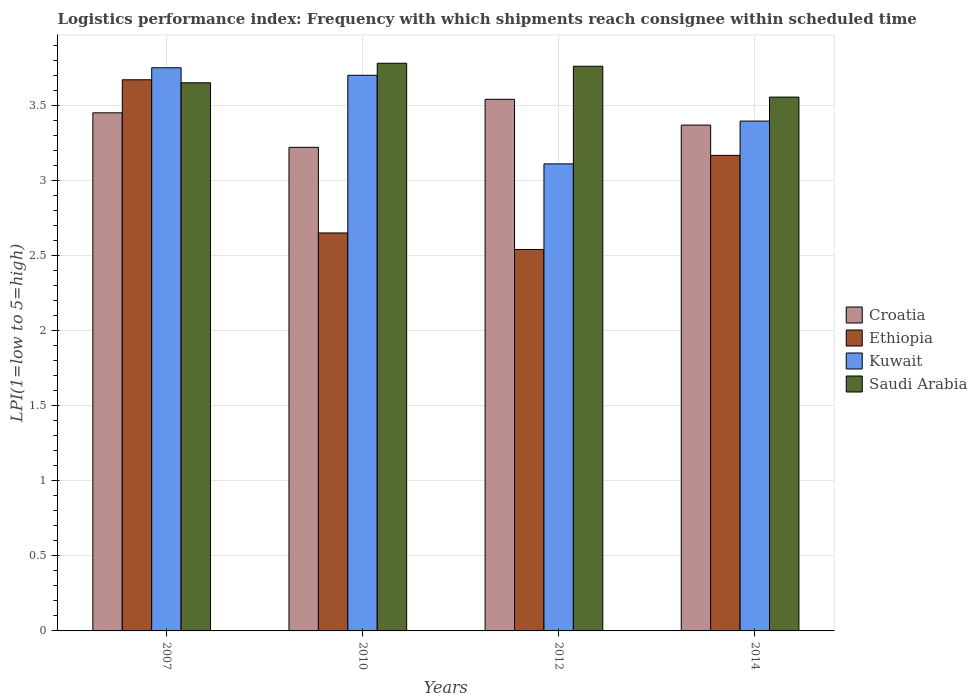How many different coloured bars are there?
Your response must be concise. 4. How many bars are there on the 2nd tick from the right?
Make the answer very short. 4. In how many cases, is the number of bars for a given year not equal to the number of legend labels?
Offer a terse response. 0. What is the logistics performance index in Croatia in 2014?
Give a very brief answer. 3.37. Across all years, what is the maximum logistics performance index in Ethiopia?
Give a very brief answer. 3.67. Across all years, what is the minimum logistics performance index in Kuwait?
Your answer should be compact. 3.11. In which year was the logistics performance index in Ethiopia maximum?
Provide a short and direct response. 2007. What is the total logistics performance index in Saudi Arabia in the graph?
Give a very brief answer. 14.74. What is the difference between the logistics performance index in Kuwait in 2010 and that in 2012?
Make the answer very short. 0.59. What is the difference between the logistics performance index in Kuwait in 2010 and the logistics performance index in Ethiopia in 2012?
Give a very brief answer. 1.16. What is the average logistics performance index in Kuwait per year?
Give a very brief answer. 3.49. In the year 2014, what is the difference between the logistics performance index in Ethiopia and logistics performance index in Croatia?
Your answer should be compact. -0.2. In how many years, is the logistics performance index in Kuwait greater than 2.3?
Your answer should be compact. 4. What is the ratio of the logistics performance index in Ethiopia in 2010 to that in 2012?
Your response must be concise. 1.04. Is the logistics performance index in Ethiopia in 2010 less than that in 2012?
Make the answer very short. No. Is the difference between the logistics performance index in Ethiopia in 2012 and 2014 greater than the difference between the logistics performance index in Croatia in 2012 and 2014?
Provide a succinct answer. No. What is the difference between the highest and the second highest logistics performance index in Croatia?
Keep it short and to the point. 0.09. What is the difference between the highest and the lowest logistics performance index in Ethiopia?
Your response must be concise. 1.13. In how many years, is the logistics performance index in Kuwait greater than the average logistics performance index in Kuwait taken over all years?
Make the answer very short. 2. Is the sum of the logistics performance index in Saudi Arabia in 2007 and 2014 greater than the maximum logistics performance index in Kuwait across all years?
Keep it short and to the point. Yes. Is it the case that in every year, the sum of the logistics performance index in Croatia and logistics performance index in Saudi Arabia is greater than the sum of logistics performance index in Ethiopia and logistics performance index in Kuwait?
Provide a succinct answer. Yes. What does the 3rd bar from the left in 2012 represents?
Your answer should be very brief. Kuwait. What does the 2nd bar from the right in 2007 represents?
Your answer should be very brief. Kuwait. Is it the case that in every year, the sum of the logistics performance index in Croatia and logistics performance index in Saudi Arabia is greater than the logistics performance index in Kuwait?
Give a very brief answer. Yes. Are all the bars in the graph horizontal?
Your answer should be very brief. No. How many years are there in the graph?
Offer a very short reply. 4. What is the difference between two consecutive major ticks on the Y-axis?
Your answer should be very brief. 0.5. Are the values on the major ticks of Y-axis written in scientific E-notation?
Give a very brief answer. No. Does the graph contain grids?
Keep it short and to the point. Yes. How many legend labels are there?
Provide a succinct answer. 4. What is the title of the graph?
Ensure brevity in your answer.  Logistics performance index: Frequency with which shipments reach consignee within scheduled time. What is the label or title of the Y-axis?
Provide a succinct answer. LPI(1=low to 5=high). What is the LPI(1=low to 5=high) of Croatia in 2007?
Make the answer very short. 3.45. What is the LPI(1=low to 5=high) of Ethiopia in 2007?
Keep it short and to the point. 3.67. What is the LPI(1=low to 5=high) in Kuwait in 2007?
Ensure brevity in your answer.  3.75. What is the LPI(1=low to 5=high) of Saudi Arabia in 2007?
Provide a short and direct response. 3.65. What is the LPI(1=low to 5=high) in Croatia in 2010?
Offer a terse response. 3.22. What is the LPI(1=low to 5=high) of Ethiopia in 2010?
Provide a succinct answer. 2.65. What is the LPI(1=low to 5=high) in Saudi Arabia in 2010?
Your answer should be compact. 3.78. What is the LPI(1=low to 5=high) in Croatia in 2012?
Your answer should be compact. 3.54. What is the LPI(1=low to 5=high) in Ethiopia in 2012?
Your answer should be compact. 2.54. What is the LPI(1=low to 5=high) of Kuwait in 2012?
Ensure brevity in your answer.  3.11. What is the LPI(1=low to 5=high) of Saudi Arabia in 2012?
Provide a succinct answer. 3.76. What is the LPI(1=low to 5=high) of Croatia in 2014?
Make the answer very short. 3.37. What is the LPI(1=low to 5=high) in Ethiopia in 2014?
Make the answer very short. 3.17. What is the LPI(1=low to 5=high) of Kuwait in 2014?
Your answer should be very brief. 3.39. What is the LPI(1=low to 5=high) in Saudi Arabia in 2014?
Your answer should be very brief. 3.55. Across all years, what is the maximum LPI(1=low to 5=high) in Croatia?
Offer a terse response. 3.54. Across all years, what is the maximum LPI(1=low to 5=high) in Ethiopia?
Your answer should be compact. 3.67. Across all years, what is the maximum LPI(1=low to 5=high) in Kuwait?
Give a very brief answer. 3.75. Across all years, what is the maximum LPI(1=low to 5=high) in Saudi Arabia?
Give a very brief answer. 3.78. Across all years, what is the minimum LPI(1=low to 5=high) in Croatia?
Your response must be concise. 3.22. Across all years, what is the minimum LPI(1=low to 5=high) of Ethiopia?
Your answer should be very brief. 2.54. Across all years, what is the minimum LPI(1=low to 5=high) in Kuwait?
Give a very brief answer. 3.11. Across all years, what is the minimum LPI(1=low to 5=high) of Saudi Arabia?
Your answer should be very brief. 3.55. What is the total LPI(1=low to 5=high) in Croatia in the graph?
Your answer should be very brief. 13.58. What is the total LPI(1=low to 5=high) of Ethiopia in the graph?
Offer a terse response. 12.03. What is the total LPI(1=low to 5=high) in Kuwait in the graph?
Provide a succinct answer. 13.96. What is the total LPI(1=low to 5=high) in Saudi Arabia in the graph?
Your response must be concise. 14.74. What is the difference between the LPI(1=low to 5=high) in Croatia in 2007 and that in 2010?
Your answer should be very brief. 0.23. What is the difference between the LPI(1=low to 5=high) in Ethiopia in 2007 and that in 2010?
Your response must be concise. 1.02. What is the difference between the LPI(1=low to 5=high) of Saudi Arabia in 2007 and that in 2010?
Your answer should be very brief. -0.13. What is the difference between the LPI(1=low to 5=high) of Croatia in 2007 and that in 2012?
Offer a terse response. -0.09. What is the difference between the LPI(1=low to 5=high) of Ethiopia in 2007 and that in 2012?
Offer a terse response. 1.13. What is the difference between the LPI(1=low to 5=high) of Kuwait in 2007 and that in 2012?
Make the answer very short. 0.64. What is the difference between the LPI(1=low to 5=high) in Saudi Arabia in 2007 and that in 2012?
Provide a short and direct response. -0.11. What is the difference between the LPI(1=low to 5=high) of Croatia in 2007 and that in 2014?
Keep it short and to the point. 0.08. What is the difference between the LPI(1=low to 5=high) in Ethiopia in 2007 and that in 2014?
Keep it short and to the point. 0.5. What is the difference between the LPI(1=low to 5=high) of Kuwait in 2007 and that in 2014?
Your answer should be very brief. 0.35. What is the difference between the LPI(1=low to 5=high) of Saudi Arabia in 2007 and that in 2014?
Keep it short and to the point. 0.1. What is the difference between the LPI(1=low to 5=high) in Croatia in 2010 and that in 2012?
Your answer should be very brief. -0.32. What is the difference between the LPI(1=low to 5=high) in Ethiopia in 2010 and that in 2012?
Offer a very short reply. 0.11. What is the difference between the LPI(1=low to 5=high) in Kuwait in 2010 and that in 2012?
Provide a succinct answer. 0.59. What is the difference between the LPI(1=low to 5=high) in Saudi Arabia in 2010 and that in 2012?
Make the answer very short. 0.02. What is the difference between the LPI(1=low to 5=high) in Croatia in 2010 and that in 2014?
Keep it short and to the point. -0.15. What is the difference between the LPI(1=low to 5=high) in Ethiopia in 2010 and that in 2014?
Your answer should be very brief. -0.52. What is the difference between the LPI(1=low to 5=high) in Kuwait in 2010 and that in 2014?
Provide a succinct answer. 0.3. What is the difference between the LPI(1=low to 5=high) of Saudi Arabia in 2010 and that in 2014?
Your answer should be compact. 0.23. What is the difference between the LPI(1=low to 5=high) of Croatia in 2012 and that in 2014?
Provide a short and direct response. 0.17. What is the difference between the LPI(1=low to 5=high) in Ethiopia in 2012 and that in 2014?
Make the answer very short. -0.63. What is the difference between the LPI(1=low to 5=high) in Kuwait in 2012 and that in 2014?
Offer a very short reply. -0.28. What is the difference between the LPI(1=low to 5=high) of Saudi Arabia in 2012 and that in 2014?
Ensure brevity in your answer.  0.21. What is the difference between the LPI(1=low to 5=high) of Croatia in 2007 and the LPI(1=low to 5=high) of Kuwait in 2010?
Your response must be concise. -0.25. What is the difference between the LPI(1=low to 5=high) of Croatia in 2007 and the LPI(1=low to 5=high) of Saudi Arabia in 2010?
Offer a terse response. -0.33. What is the difference between the LPI(1=low to 5=high) in Ethiopia in 2007 and the LPI(1=low to 5=high) in Kuwait in 2010?
Offer a terse response. -0.03. What is the difference between the LPI(1=low to 5=high) of Ethiopia in 2007 and the LPI(1=low to 5=high) of Saudi Arabia in 2010?
Provide a succinct answer. -0.11. What is the difference between the LPI(1=low to 5=high) of Kuwait in 2007 and the LPI(1=low to 5=high) of Saudi Arabia in 2010?
Your answer should be compact. -0.03. What is the difference between the LPI(1=low to 5=high) in Croatia in 2007 and the LPI(1=low to 5=high) in Ethiopia in 2012?
Your answer should be compact. 0.91. What is the difference between the LPI(1=low to 5=high) in Croatia in 2007 and the LPI(1=low to 5=high) in Kuwait in 2012?
Offer a terse response. 0.34. What is the difference between the LPI(1=low to 5=high) in Croatia in 2007 and the LPI(1=low to 5=high) in Saudi Arabia in 2012?
Offer a terse response. -0.31. What is the difference between the LPI(1=low to 5=high) in Ethiopia in 2007 and the LPI(1=low to 5=high) in Kuwait in 2012?
Provide a succinct answer. 0.56. What is the difference between the LPI(1=low to 5=high) of Ethiopia in 2007 and the LPI(1=low to 5=high) of Saudi Arabia in 2012?
Your answer should be compact. -0.09. What is the difference between the LPI(1=low to 5=high) in Kuwait in 2007 and the LPI(1=low to 5=high) in Saudi Arabia in 2012?
Make the answer very short. -0.01. What is the difference between the LPI(1=low to 5=high) of Croatia in 2007 and the LPI(1=low to 5=high) of Ethiopia in 2014?
Keep it short and to the point. 0.28. What is the difference between the LPI(1=low to 5=high) of Croatia in 2007 and the LPI(1=low to 5=high) of Kuwait in 2014?
Make the answer very short. 0.06. What is the difference between the LPI(1=low to 5=high) in Croatia in 2007 and the LPI(1=low to 5=high) in Saudi Arabia in 2014?
Your answer should be compact. -0.1. What is the difference between the LPI(1=low to 5=high) in Ethiopia in 2007 and the LPI(1=low to 5=high) in Kuwait in 2014?
Keep it short and to the point. 0.28. What is the difference between the LPI(1=low to 5=high) of Ethiopia in 2007 and the LPI(1=low to 5=high) of Saudi Arabia in 2014?
Keep it short and to the point. 0.12. What is the difference between the LPI(1=low to 5=high) in Kuwait in 2007 and the LPI(1=low to 5=high) in Saudi Arabia in 2014?
Your answer should be compact. 0.2. What is the difference between the LPI(1=low to 5=high) of Croatia in 2010 and the LPI(1=low to 5=high) of Ethiopia in 2012?
Offer a terse response. 0.68. What is the difference between the LPI(1=low to 5=high) of Croatia in 2010 and the LPI(1=low to 5=high) of Kuwait in 2012?
Offer a terse response. 0.11. What is the difference between the LPI(1=low to 5=high) in Croatia in 2010 and the LPI(1=low to 5=high) in Saudi Arabia in 2012?
Offer a very short reply. -0.54. What is the difference between the LPI(1=low to 5=high) in Ethiopia in 2010 and the LPI(1=low to 5=high) in Kuwait in 2012?
Provide a succinct answer. -0.46. What is the difference between the LPI(1=low to 5=high) of Ethiopia in 2010 and the LPI(1=low to 5=high) of Saudi Arabia in 2012?
Provide a succinct answer. -1.11. What is the difference between the LPI(1=low to 5=high) of Kuwait in 2010 and the LPI(1=low to 5=high) of Saudi Arabia in 2012?
Your response must be concise. -0.06. What is the difference between the LPI(1=low to 5=high) in Croatia in 2010 and the LPI(1=low to 5=high) in Ethiopia in 2014?
Provide a succinct answer. 0.05. What is the difference between the LPI(1=low to 5=high) of Croatia in 2010 and the LPI(1=low to 5=high) of Kuwait in 2014?
Make the answer very short. -0.17. What is the difference between the LPI(1=low to 5=high) of Croatia in 2010 and the LPI(1=low to 5=high) of Saudi Arabia in 2014?
Your response must be concise. -0.33. What is the difference between the LPI(1=low to 5=high) of Ethiopia in 2010 and the LPI(1=low to 5=high) of Kuwait in 2014?
Provide a succinct answer. -0.74. What is the difference between the LPI(1=low to 5=high) in Ethiopia in 2010 and the LPI(1=low to 5=high) in Saudi Arabia in 2014?
Offer a very short reply. -0.9. What is the difference between the LPI(1=low to 5=high) of Kuwait in 2010 and the LPI(1=low to 5=high) of Saudi Arabia in 2014?
Your answer should be very brief. 0.15. What is the difference between the LPI(1=low to 5=high) of Croatia in 2012 and the LPI(1=low to 5=high) of Ethiopia in 2014?
Your response must be concise. 0.37. What is the difference between the LPI(1=low to 5=high) in Croatia in 2012 and the LPI(1=low to 5=high) in Kuwait in 2014?
Offer a terse response. 0.14. What is the difference between the LPI(1=low to 5=high) of Croatia in 2012 and the LPI(1=low to 5=high) of Saudi Arabia in 2014?
Provide a short and direct response. -0.01. What is the difference between the LPI(1=low to 5=high) in Ethiopia in 2012 and the LPI(1=low to 5=high) in Kuwait in 2014?
Offer a terse response. -0.85. What is the difference between the LPI(1=low to 5=high) of Ethiopia in 2012 and the LPI(1=low to 5=high) of Saudi Arabia in 2014?
Provide a short and direct response. -1.01. What is the difference between the LPI(1=low to 5=high) of Kuwait in 2012 and the LPI(1=low to 5=high) of Saudi Arabia in 2014?
Make the answer very short. -0.44. What is the average LPI(1=low to 5=high) of Croatia per year?
Give a very brief answer. 3.39. What is the average LPI(1=low to 5=high) in Ethiopia per year?
Give a very brief answer. 3.01. What is the average LPI(1=low to 5=high) of Kuwait per year?
Your answer should be very brief. 3.49. What is the average LPI(1=low to 5=high) in Saudi Arabia per year?
Give a very brief answer. 3.69. In the year 2007, what is the difference between the LPI(1=low to 5=high) in Croatia and LPI(1=low to 5=high) in Ethiopia?
Offer a terse response. -0.22. In the year 2007, what is the difference between the LPI(1=low to 5=high) of Croatia and LPI(1=low to 5=high) of Kuwait?
Your answer should be compact. -0.3. In the year 2007, what is the difference between the LPI(1=low to 5=high) of Ethiopia and LPI(1=low to 5=high) of Kuwait?
Provide a succinct answer. -0.08. In the year 2007, what is the difference between the LPI(1=low to 5=high) of Kuwait and LPI(1=low to 5=high) of Saudi Arabia?
Offer a terse response. 0.1. In the year 2010, what is the difference between the LPI(1=low to 5=high) of Croatia and LPI(1=low to 5=high) of Ethiopia?
Keep it short and to the point. 0.57. In the year 2010, what is the difference between the LPI(1=low to 5=high) of Croatia and LPI(1=low to 5=high) of Kuwait?
Give a very brief answer. -0.48. In the year 2010, what is the difference between the LPI(1=low to 5=high) of Croatia and LPI(1=low to 5=high) of Saudi Arabia?
Offer a very short reply. -0.56. In the year 2010, what is the difference between the LPI(1=low to 5=high) of Ethiopia and LPI(1=low to 5=high) of Kuwait?
Make the answer very short. -1.05. In the year 2010, what is the difference between the LPI(1=low to 5=high) of Ethiopia and LPI(1=low to 5=high) of Saudi Arabia?
Offer a terse response. -1.13. In the year 2010, what is the difference between the LPI(1=low to 5=high) of Kuwait and LPI(1=low to 5=high) of Saudi Arabia?
Offer a terse response. -0.08. In the year 2012, what is the difference between the LPI(1=low to 5=high) in Croatia and LPI(1=low to 5=high) in Ethiopia?
Give a very brief answer. 1. In the year 2012, what is the difference between the LPI(1=low to 5=high) of Croatia and LPI(1=low to 5=high) of Kuwait?
Your answer should be compact. 0.43. In the year 2012, what is the difference between the LPI(1=low to 5=high) of Croatia and LPI(1=low to 5=high) of Saudi Arabia?
Keep it short and to the point. -0.22. In the year 2012, what is the difference between the LPI(1=low to 5=high) in Ethiopia and LPI(1=low to 5=high) in Kuwait?
Your answer should be very brief. -0.57. In the year 2012, what is the difference between the LPI(1=low to 5=high) in Ethiopia and LPI(1=low to 5=high) in Saudi Arabia?
Offer a terse response. -1.22. In the year 2012, what is the difference between the LPI(1=low to 5=high) in Kuwait and LPI(1=low to 5=high) in Saudi Arabia?
Provide a short and direct response. -0.65. In the year 2014, what is the difference between the LPI(1=low to 5=high) in Croatia and LPI(1=low to 5=high) in Ethiopia?
Keep it short and to the point. 0.2. In the year 2014, what is the difference between the LPI(1=low to 5=high) of Croatia and LPI(1=low to 5=high) of Kuwait?
Make the answer very short. -0.03. In the year 2014, what is the difference between the LPI(1=low to 5=high) of Croatia and LPI(1=low to 5=high) of Saudi Arabia?
Provide a succinct answer. -0.19. In the year 2014, what is the difference between the LPI(1=low to 5=high) of Ethiopia and LPI(1=low to 5=high) of Kuwait?
Give a very brief answer. -0.23. In the year 2014, what is the difference between the LPI(1=low to 5=high) of Ethiopia and LPI(1=low to 5=high) of Saudi Arabia?
Your answer should be very brief. -0.39. In the year 2014, what is the difference between the LPI(1=low to 5=high) of Kuwait and LPI(1=low to 5=high) of Saudi Arabia?
Provide a succinct answer. -0.16. What is the ratio of the LPI(1=low to 5=high) of Croatia in 2007 to that in 2010?
Keep it short and to the point. 1.07. What is the ratio of the LPI(1=low to 5=high) of Ethiopia in 2007 to that in 2010?
Provide a succinct answer. 1.38. What is the ratio of the LPI(1=low to 5=high) of Kuwait in 2007 to that in 2010?
Provide a succinct answer. 1.01. What is the ratio of the LPI(1=low to 5=high) in Saudi Arabia in 2007 to that in 2010?
Your response must be concise. 0.97. What is the ratio of the LPI(1=low to 5=high) of Croatia in 2007 to that in 2012?
Give a very brief answer. 0.97. What is the ratio of the LPI(1=low to 5=high) in Ethiopia in 2007 to that in 2012?
Keep it short and to the point. 1.44. What is the ratio of the LPI(1=low to 5=high) in Kuwait in 2007 to that in 2012?
Ensure brevity in your answer.  1.21. What is the ratio of the LPI(1=low to 5=high) in Saudi Arabia in 2007 to that in 2012?
Offer a terse response. 0.97. What is the ratio of the LPI(1=low to 5=high) in Croatia in 2007 to that in 2014?
Give a very brief answer. 1.02. What is the ratio of the LPI(1=low to 5=high) of Ethiopia in 2007 to that in 2014?
Ensure brevity in your answer.  1.16. What is the ratio of the LPI(1=low to 5=high) in Kuwait in 2007 to that in 2014?
Your answer should be very brief. 1.1. What is the ratio of the LPI(1=low to 5=high) of Saudi Arabia in 2007 to that in 2014?
Provide a succinct answer. 1.03. What is the ratio of the LPI(1=low to 5=high) of Croatia in 2010 to that in 2012?
Your answer should be compact. 0.91. What is the ratio of the LPI(1=low to 5=high) in Ethiopia in 2010 to that in 2012?
Provide a short and direct response. 1.04. What is the ratio of the LPI(1=low to 5=high) in Kuwait in 2010 to that in 2012?
Offer a terse response. 1.19. What is the ratio of the LPI(1=low to 5=high) in Croatia in 2010 to that in 2014?
Your answer should be compact. 0.96. What is the ratio of the LPI(1=low to 5=high) in Ethiopia in 2010 to that in 2014?
Your answer should be very brief. 0.84. What is the ratio of the LPI(1=low to 5=high) in Kuwait in 2010 to that in 2014?
Your answer should be compact. 1.09. What is the ratio of the LPI(1=low to 5=high) of Saudi Arabia in 2010 to that in 2014?
Give a very brief answer. 1.06. What is the ratio of the LPI(1=low to 5=high) in Croatia in 2012 to that in 2014?
Your answer should be compact. 1.05. What is the ratio of the LPI(1=low to 5=high) of Ethiopia in 2012 to that in 2014?
Offer a very short reply. 0.8. What is the ratio of the LPI(1=low to 5=high) of Kuwait in 2012 to that in 2014?
Provide a short and direct response. 0.92. What is the ratio of the LPI(1=low to 5=high) of Saudi Arabia in 2012 to that in 2014?
Provide a succinct answer. 1.06. What is the difference between the highest and the second highest LPI(1=low to 5=high) of Croatia?
Your answer should be compact. 0.09. What is the difference between the highest and the second highest LPI(1=low to 5=high) of Ethiopia?
Your answer should be very brief. 0.5. What is the difference between the highest and the second highest LPI(1=low to 5=high) of Kuwait?
Offer a very short reply. 0.05. What is the difference between the highest and the second highest LPI(1=low to 5=high) of Saudi Arabia?
Provide a succinct answer. 0.02. What is the difference between the highest and the lowest LPI(1=low to 5=high) of Croatia?
Provide a short and direct response. 0.32. What is the difference between the highest and the lowest LPI(1=low to 5=high) in Ethiopia?
Ensure brevity in your answer.  1.13. What is the difference between the highest and the lowest LPI(1=low to 5=high) of Kuwait?
Give a very brief answer. 0.64. What is the difference between the highest and the lowest LPI(1=low to 5=high) in Saudi Arabia?
Keep it short and to the point. 0.23. 